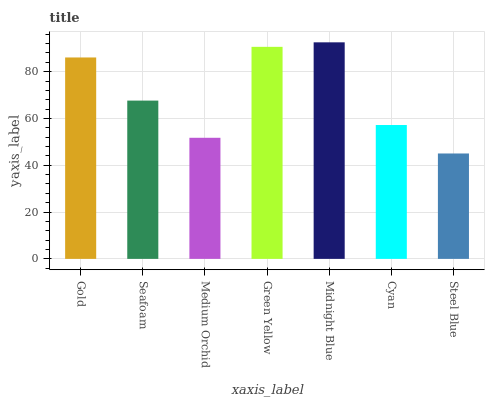Is Steel Blue the minimum?
Answer yes or no. Yes. Is Midnight Blue the maximum?
Answer yes or no. Yes. Is Seafoam the minimum?
Answer yes or no. No. Is Seafoam the maximum?
Answer yes or no. No. Is Gold greater than Seafoam?
Answer yes or no. Yes. Is Seafoam less than Gold?
Answer yes or no. Yes. Is Seafoam greater than Gold?
Answer yes or no. No. Is Gold less than Seafoam?
Answer yes or no. No. Is Seafoam the high median?
Answer yes or no. Yes. Is Seafoam the low median?
Answer yes or no. Yes. Is Cyan the high median?
Answer yes or no. No. Is Gold the low median?
Answer yes or no. No. 